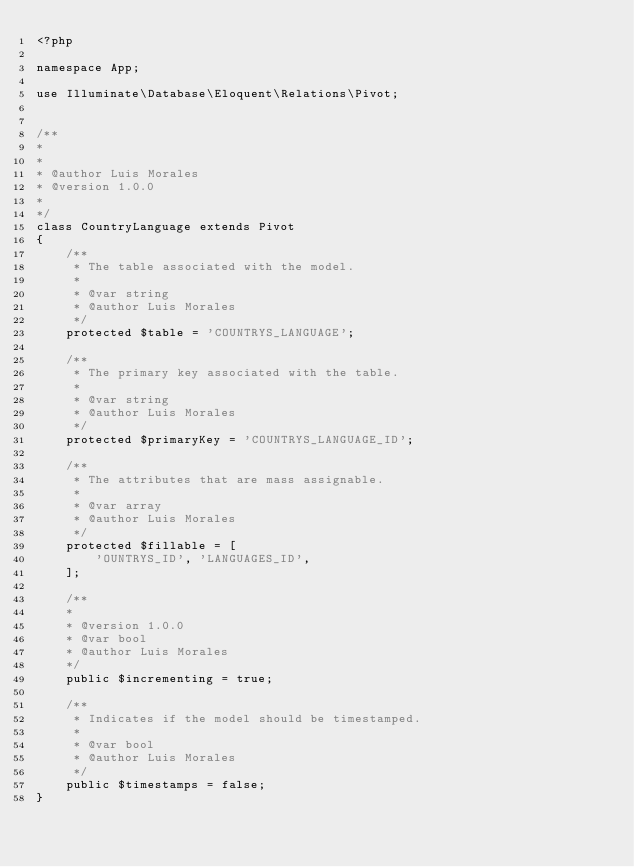<code> <loc_0><loc_0><loc_500><loc_500><_PHP_><?php

namespace App;

use Illuminate\Database\Eloquent\Relations\Pivot;


/**
*
*
* @author Luis Morales
* @version 1.0.0
*
*/
class CountryLanguage extends Pivot
{
    /**
     * The table associated with the model.
     * 
     * @var string
     * @author Luis Morales
     */
    protected $table = 'COUNTRYS_LANGUAGE';

    /**
     * The primary key associated with the table.
     *
     * @var string
     * @author Luis Morales
     */
    protected $primaryKey = 'COUNTRYS_LANGUAGE_ID';

    /**
     * The attributes that are mass assignable.
     *
     * @var array
     * @author Luis Morales
     */
    protected $fillable = [
        'OUNTRYS_ID', 'LANGUAGES_ID', 
    ];

    /**
    *
    * @version 1.0.0
    * @var bool
    * @author Luis Morales
    */
    public $incrementing = true;

    /**
     * Indicates if the model should be timestamped.
     *
     * @var bool
     * @author Luis Morales
     */
    public $timestamps = false;
}
</code> 